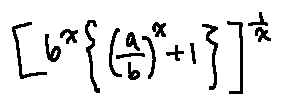<formula> <loc_0><loc_0><loc_500><loc_500>[ b ^ { x } \{ ( \frac { a } { b } ) ^ { x } + 1 \} ] ^ { \frac { 1 } { x } }</formula> 